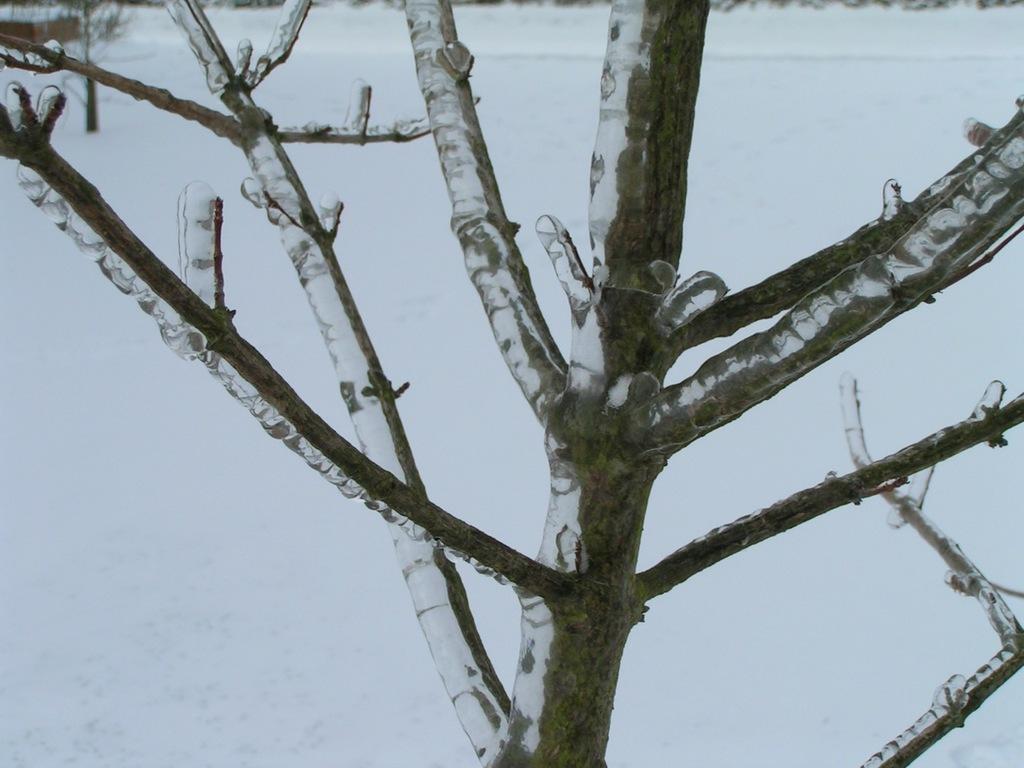Describe this image in one or two sentences. In this image there is a tree. There is snow on the tree. In the background there is snow on the ground. 